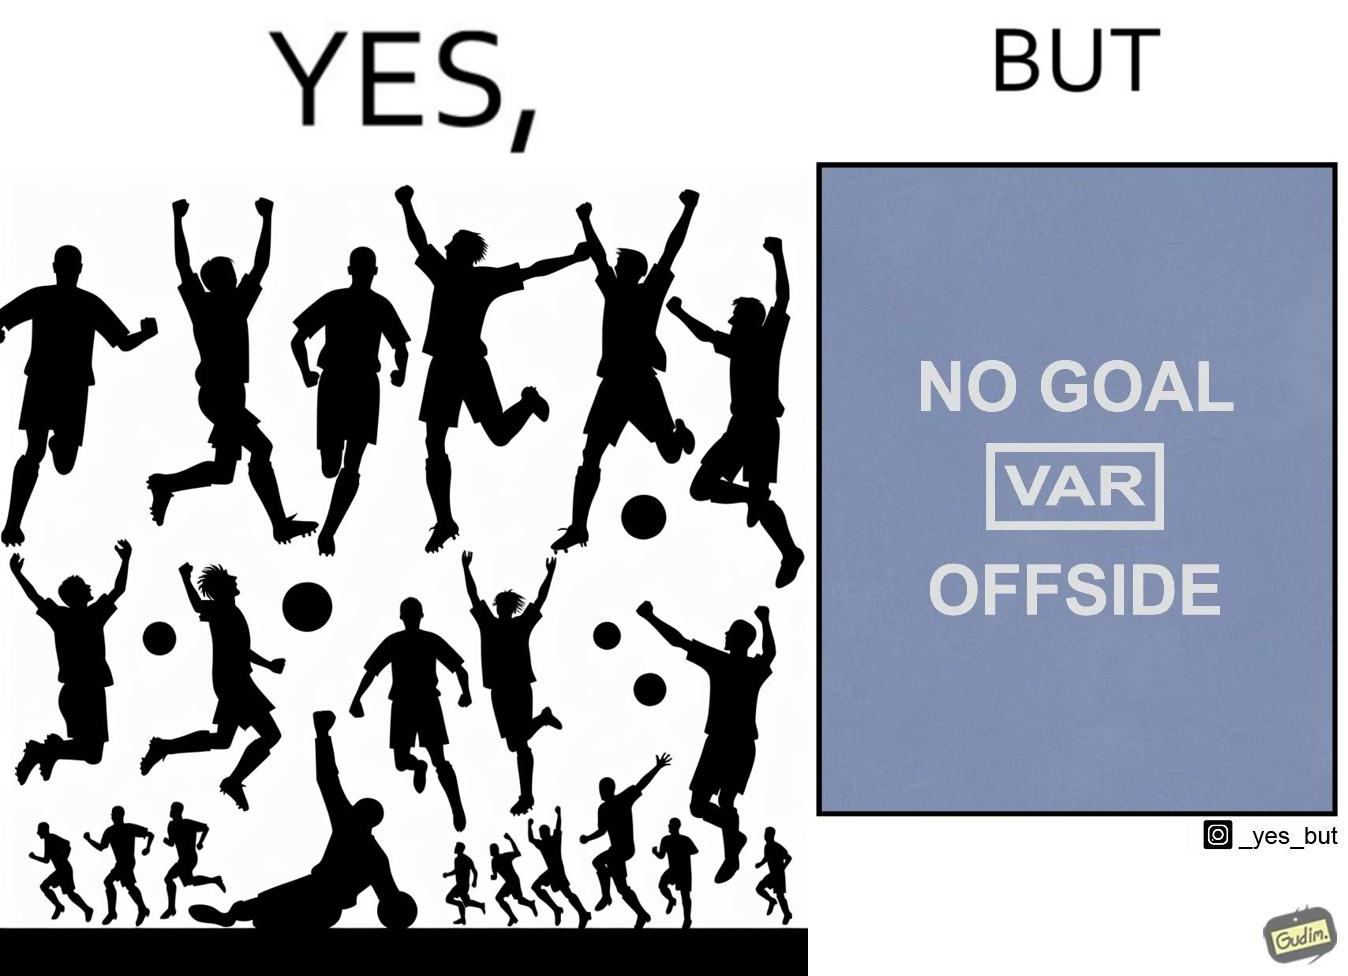Describe the content of this image. The image is ironical, as the team is celebrating as they think that they have scored a goal, but the sign on the screen says that it is an offside, and not a goal. This is a very common scenario in football matches. 